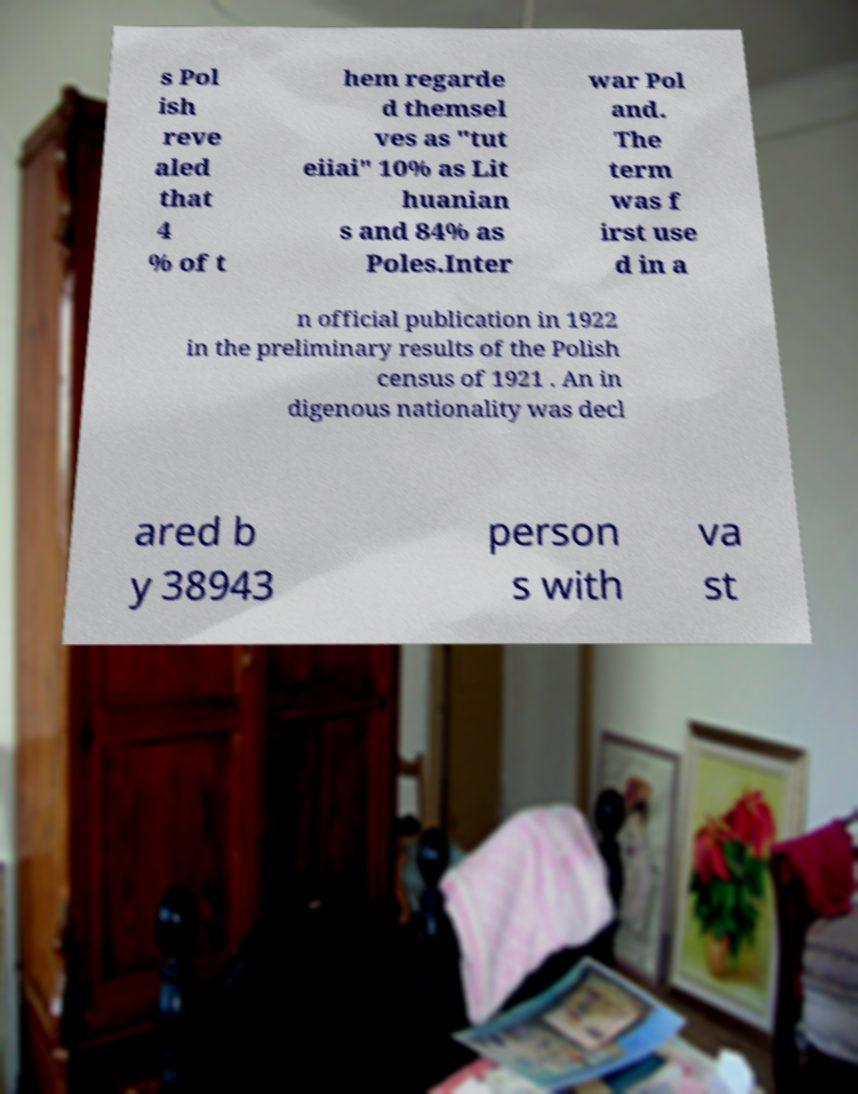Could you extract and type out the text from this image? s Pol ish reve aled that 4 % of t hem regarde d themsel ves as "tut eiiai" 10% as Lit huanian s and 84% as Poles.Inter war Pol and. The term was f irst use d in a n official publication in 1922 in the preliminary results of the Polish census of 1921 . An in digenous nationality was decl ared b y 38943 person s with va st 